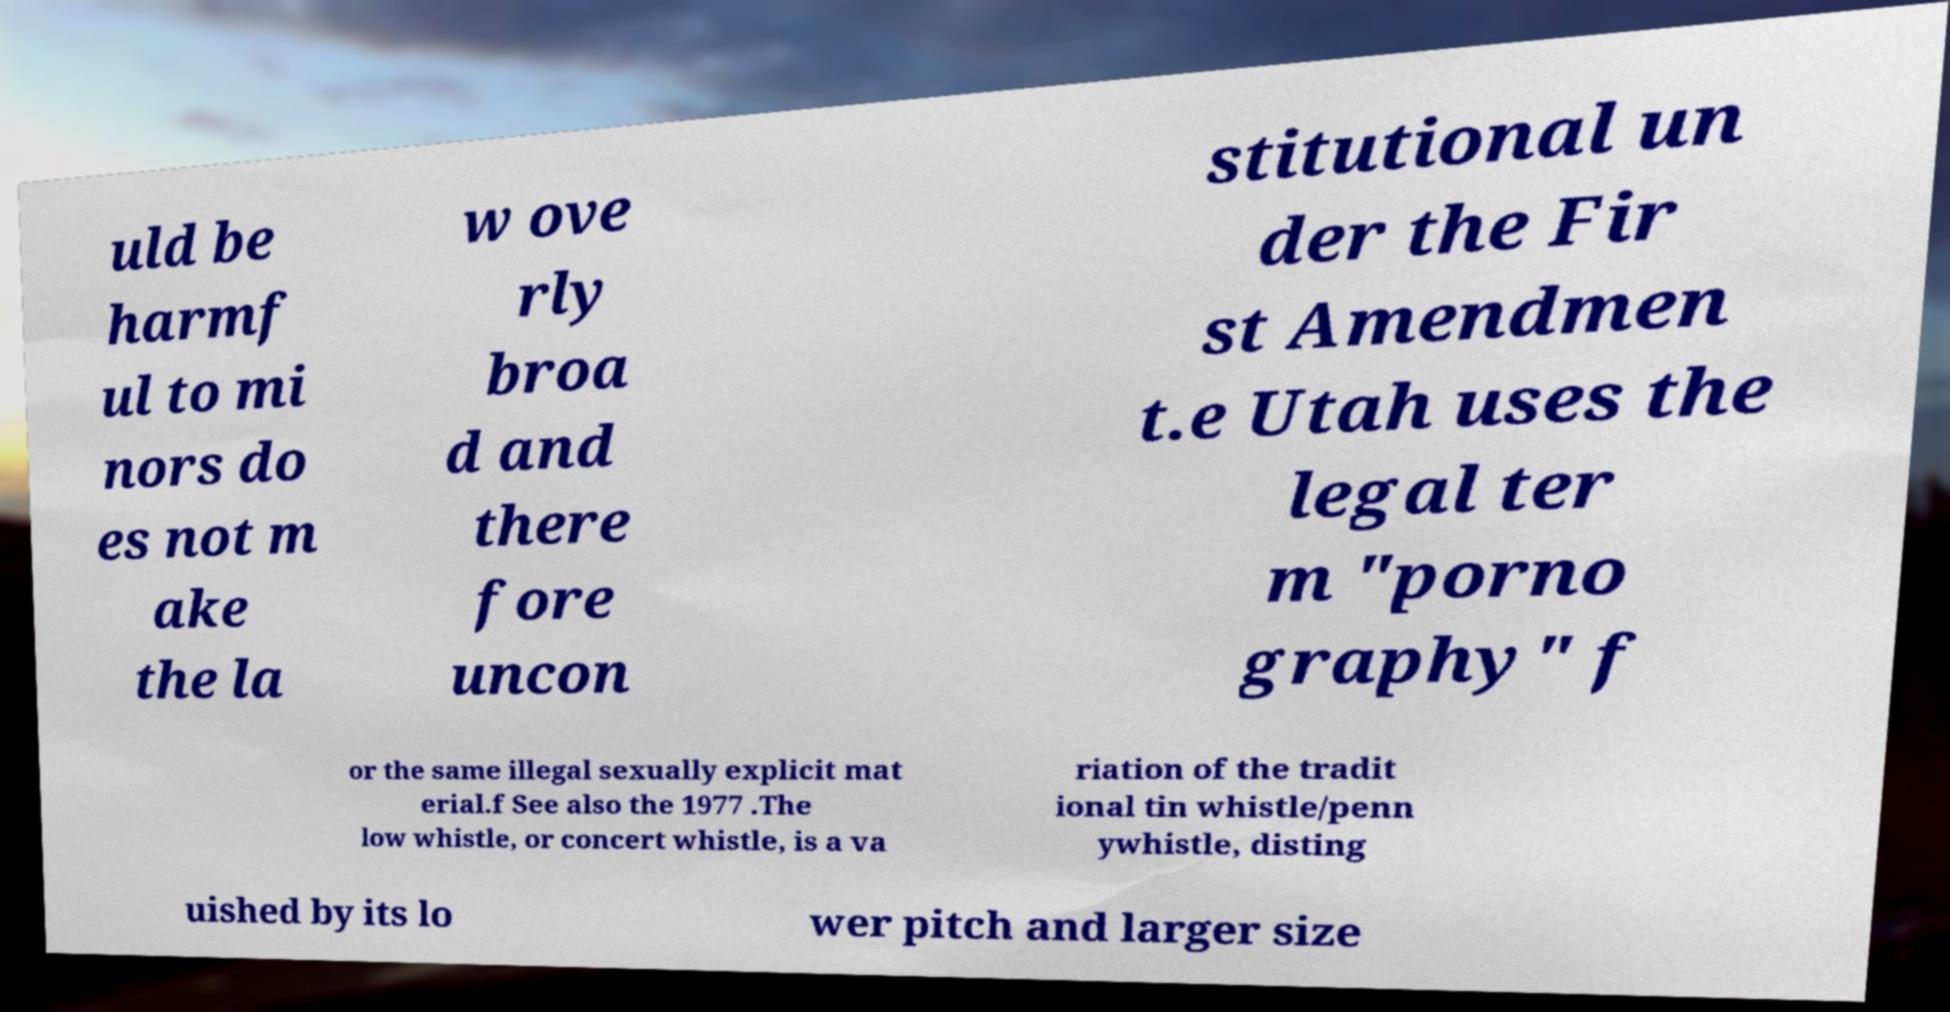Could you extract and type out the text from this image? uld be harmf ul to mi nors do es not m ake the la w ove rly broa d and there fore uncon stitutional un der the Fir st Amendmen t.e Utah uses the legal ter m "porno graphy" f or the same illegal sexually explicit mat erial.f See also the 1977 .The low whistle, or concert whistle, is a va riation of the tradit ional tin whistle/penn ywhistle, disting uished by its lo wer pitch and larger size 